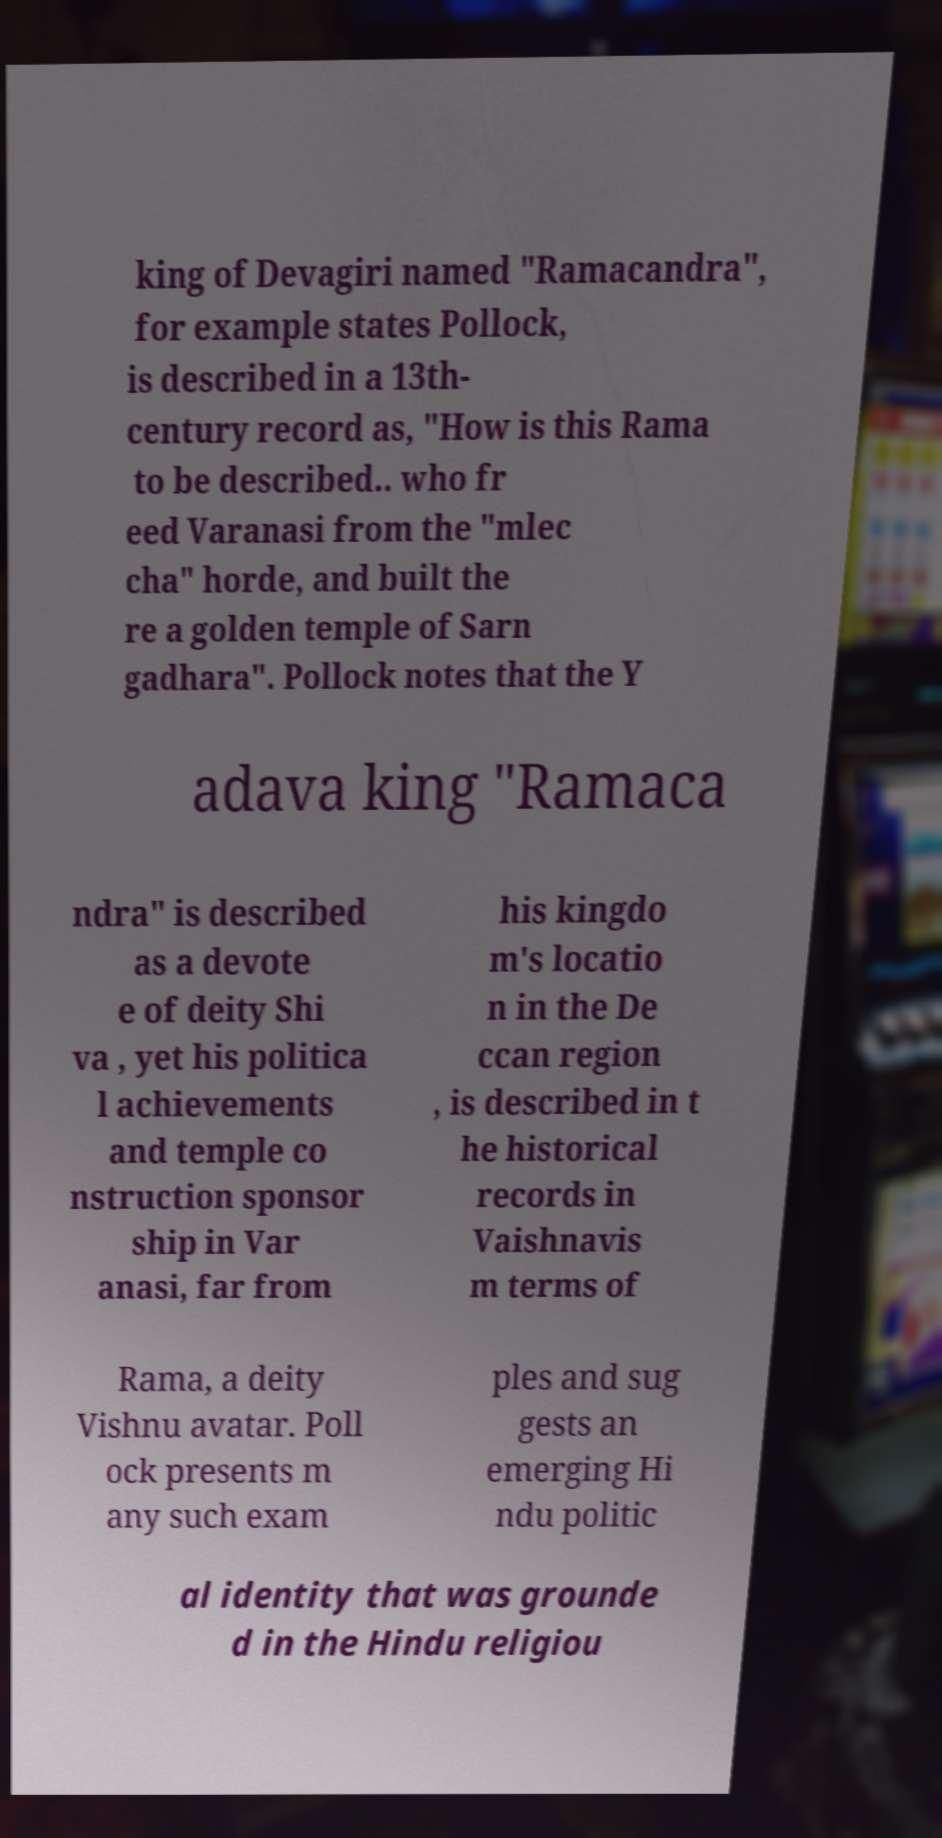Can you accurately transcribe the text from the provided image for me? king of Devagiri named "Ramacandra", for example states Pollock, is described in a 13th- century record as, "How is this Rama to be described.. who fr eed Varanasi from the "mlec cha" horde, and built the re a golden temple of Sarn gadhara". Pollock notes that the Y adava king "Ramaca ndra" is described as a devote e of deity Shi va , yet his politica l achievements and temple co nstruction sponsor ship in Var anasi, far from his kingdo m's locatio n in the De ccan region , is described in t he historical records in Vaishnavis m terms of Rama, a deity Vishnu avatar. Poll ock presents m any such exam ples and sug gests an emerging Hi ndu politic al identity that was grounde d in the Hindu religiou 